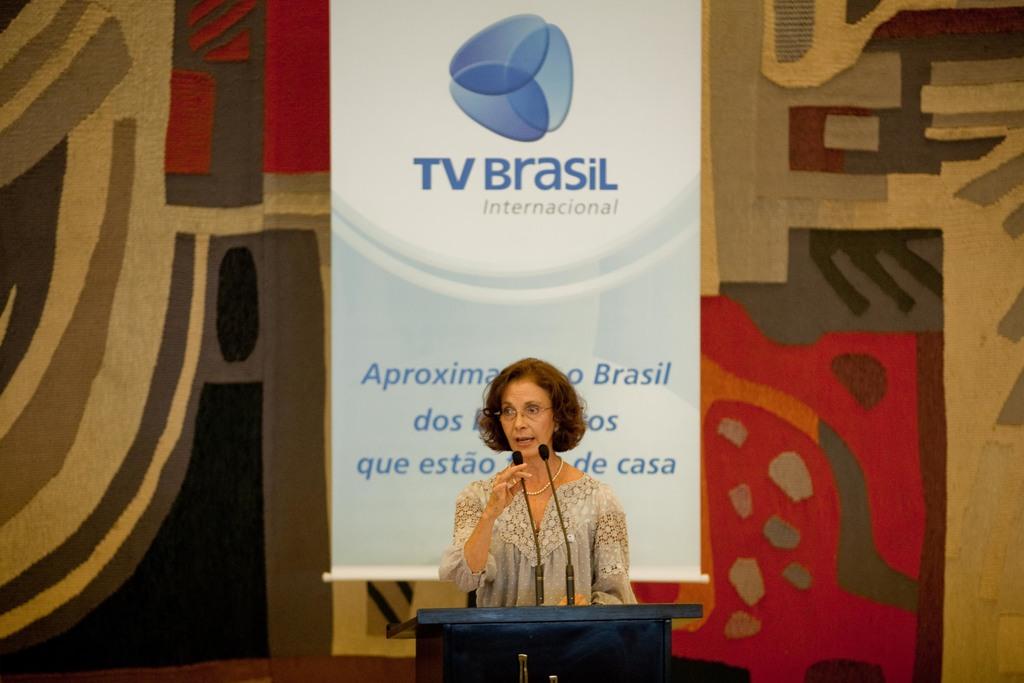What nation is this company from?
Your answer should be very brief. Brasil. What kind of company is it?
Offer a terse response. Tv brasil. 